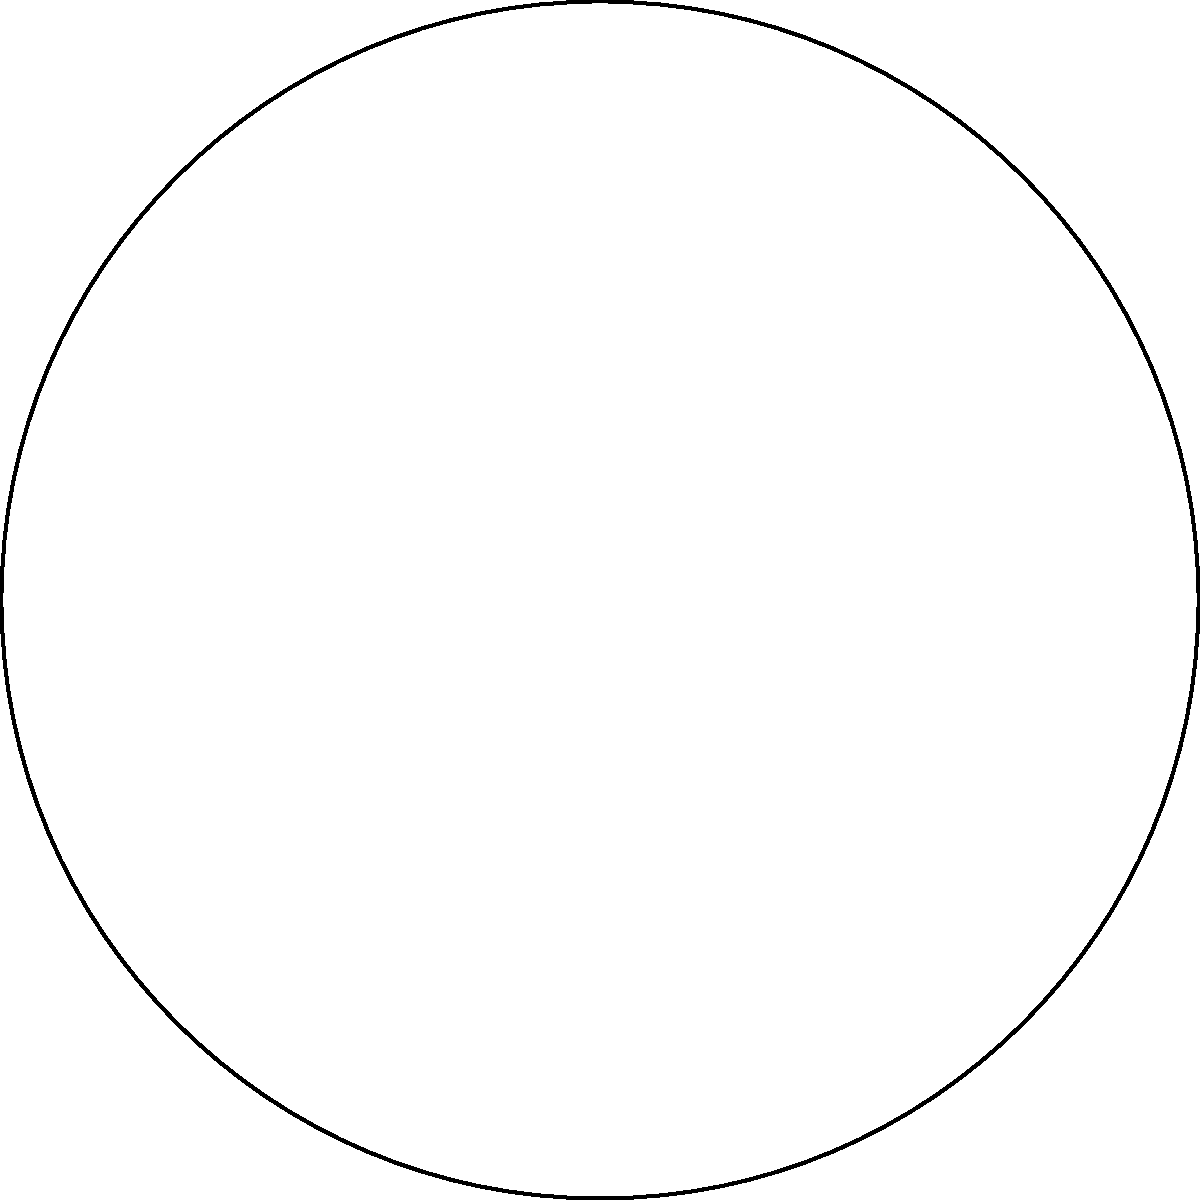As part of an interfaith baking initiative, you are arranging cookies on a circular tray. The tray has a radius of 10 inches. You have square cookies with sides of 3 inches and circular cookies with a diameter of 2 inches. If you want to maximize the number of cookies on the tray while maintaining at least 0.5 inches of space between each cookie and the edge of the tray, what is the maximum number of cookies you can fit? Let's approach this step-by-step:

1) First, we need to consider the effective radius of the tray. Since we need 0.5 inches of space from the edge, the effective radius is 9.5 inches.

2) For the square cookies:
   - The diagonal of a square cookie is $3\sqrt{2} \approx 4.24$ inches
   - The radius of a circle that would enclose this square is half of this, so $\frac{3\sqrt{2}}{2} \approx 2.12$ inches

3) For the circular cookies:
   - They already have a radius of 1 inch

4) Now, we can treat both types of cookies as circles for arrangement purposes. The square cookies need a circular space with radius 2.12 inches, and the circular cookies need a space with radius 1 inch.

5) To maximize the number of cookies, we should arrange them in concentric circles:

   - The outermost circle can fit: $\lfloor \frac{2\pi(9.5)}{2(2.12+0.5)} \rfloor = 13$ square cookies
   - The next circle can fit: $\lfloor \frac{2\pi(9.5-2.62)}{2(1+0.5)} \rfloor = 14$ circular cookies
   - The next circle can fit: $\lfloor \frac{2\pi(9.5-2.62-1.5)}{2(1+0.5)} \rfloor = 11$ circular cookies
   - In the center, we can fit 1 square cookie

6) Therefore, the maximum number of cookies is 13 + 14 + 11 + 1 = 39 cookies.
Answer: 39 cookies 